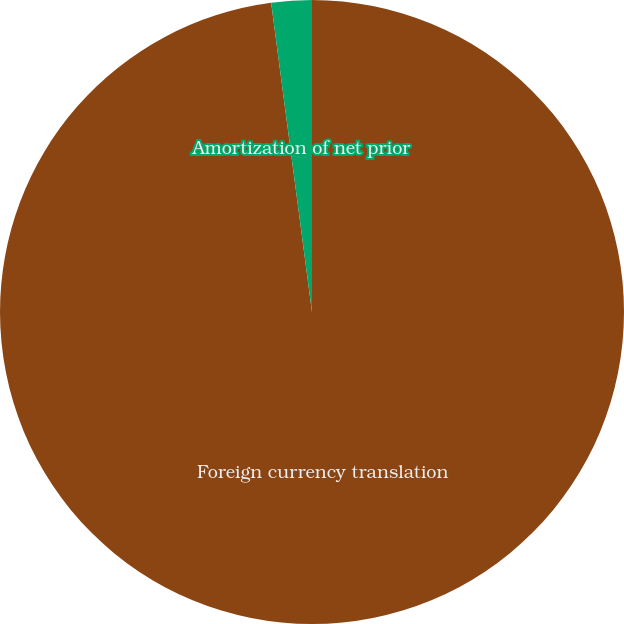Convert chart. <chart><loc_0><loc_0><loc_500><loc_500><pie_chart><fcel>Foreign currency translation<fcel>Amortization of net prior<nl><fcel>97.91%<fcel>2.09%<nl></chart> 